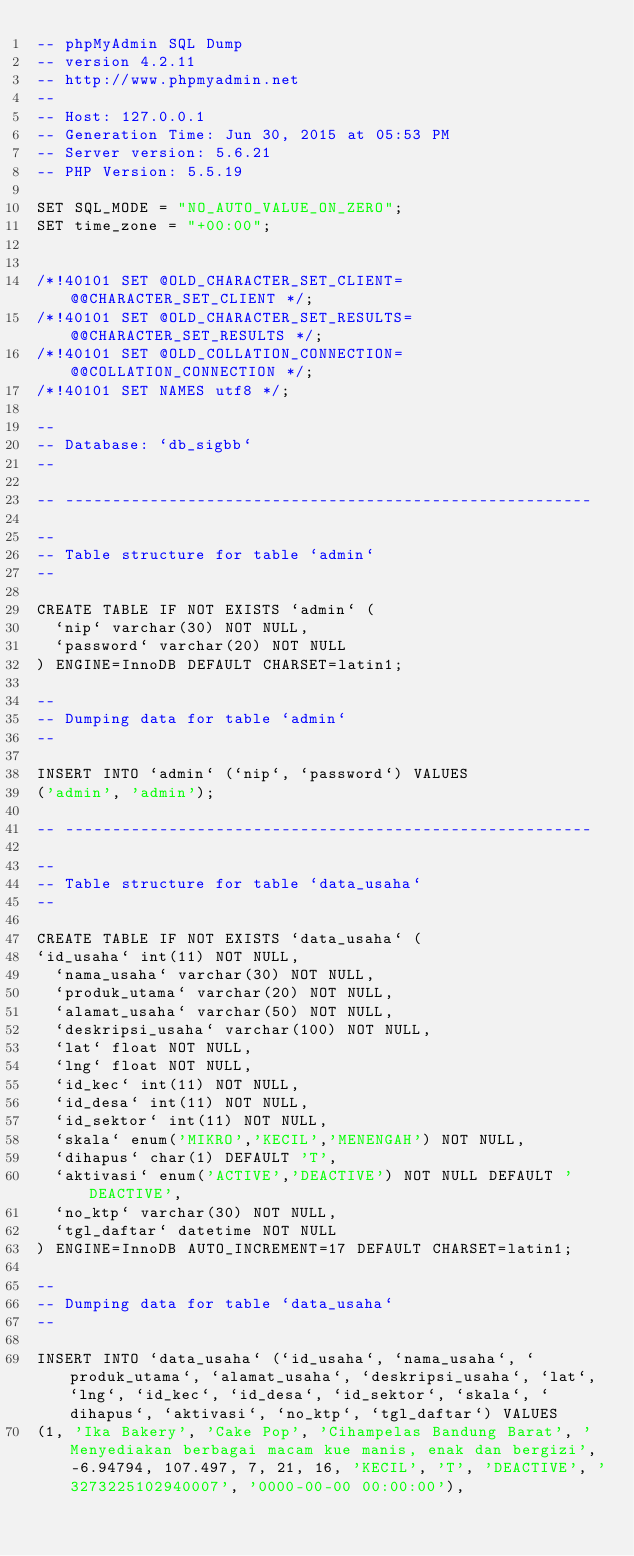<code> <loc_0><loc_0><loc_500><loc_500><_SQL_>-- phpMyAdmin SQL Dump
-- version 4.2.11
-- http://www.phpmyadmin.net
--
-- Host: 127.0.0.1
-- Generation Time: Jun 30, 2015 at 05:53 PM
-- Server version: 5.6.21
-- PHP Version: 5.5.19

SET SQL_MODE = "NO_AUTO_VALUE_ON_ZERO";
SET time_zone = "+00:00";


/*!40101 SET @OLD_CHARACTER_SET_CLIENT=@@CHARACTER_SET_CLIENT */;
/*!40101 SET @OLD_CHARACTER_SET_RESULTS=@@CHARACTER_SET_RESULTS */;
/*!40101 SET @OLD_COLLATION_CONNECTION=@@COLLATION_CONNECTION */;
/*!40101 SET NAMES utf8 */;

--
-- Database: `db_sigbb`
--

-- --------------------------------------------------------

--
-- Table structure for table `admin`
--

CREATE TABLE IF NOT EXISTS `admin` (
  `nip` varchar(30) NOT NULL,
  `password` varchar(20) NOT NULL
) ENGINE=InnoDB DEFAULT CHARSET=latin1;

--
-- Dumping data for table `admin`
--

INSERT INTO `admin` (`nip`, `password`) VALUES
('admin', 'admin');

-- --------------------------------------------------------

--
-- Table structure for table `data_usaha`
--

CREATE TABLE IF NOT EXISTS `data_usaha` (
`id_usaha` int(11) NOT NULL,
  `nama_usaha` varchar(30) NOT NULL,
  `produk_utama` varchar(20) NOT NULL,
  `alamat_usaha` varchar(50) NOT NULL,
  `deskripsi_usaha` varchar(100) NOT NULL,
  `lat` float NOT NULL,
  `lng` float NOT NULL,
  `id_kec` int(11) NOT NULL,
  `id_desa` int(11) NOT NULL,
  `id_sektor` int(11) NOT NULL,
  `skala` enum('MIKRO','KECIL','MENENGAH') NOT NULL,
  `dihapus` char(1) DEFAULT 'T',
  `aktivasi` enum('ACTIVE','DEACTIVE') NOT NULL DEFAULT 'DEACTIVE',
  `no_ktp` varchar(30) NOT NULL,
  `tgl_daftar` datetime NOT NULL
) ENGINE=InnoDB AUTO_INCREMENT=17 DEFAULT CHARSET=latin1;

--
-- Dumping data for table `data_usaha`
--

INSERT INTO `data_usaha` (`id_usaha`, `nama_usaha`, `produk_utama`, `alamat_usaha`, `deskripsi_usaha`, `lat`, `lng`, `id_kec`, `id_desa`, `id_sektor`, `skala`, `dihapus`, `aktivasi`, `no_ktp`, `tgl_daftar`) VALUES
(1, 'Ika Bakery', 'Cake Pop', 'Cihampelas Bandung Barat', 'Menyediakan berbagai macam kue manis, enak dan bergizi', -6.94794, 107.497, 7, 21, 16, 'KECIL', 'T', 'DEACTIVE', '3273225102940007', '0000-00-00 00:00:00'),</code> 